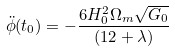Convert formula to latex. <formula><loc_0><loc_0><loc_500><loc_500>\ddot { \phi } ( t _ { 0 } ) = - \frac { 6 H _ { 0 } ^ { 2 } \Omega _ { m } \sqrt { G _ { 0 } } } { ( 1 2 + \lambda ) }</formula> 